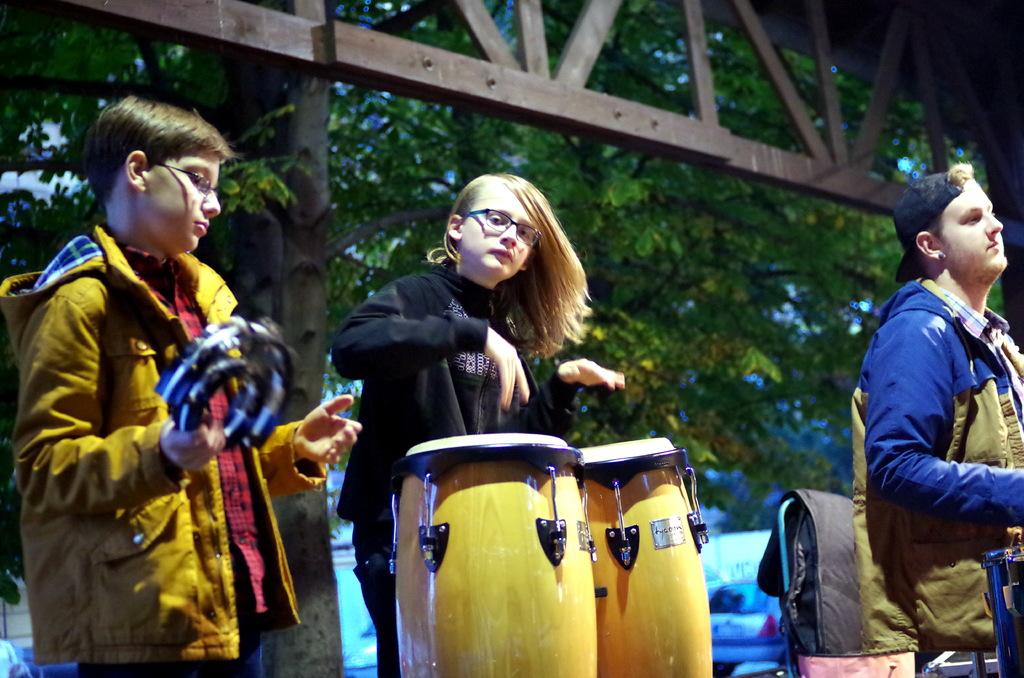How many people are present in the image? There are three people in the image. What are the people doing in the image? The people are playing musical instruments. What can be seen in the background of the image? There are trees and cars in the background of the image. What time of day is it in the image, and how many girls are present? The time of day is not mentioned in the image, and there is no indication of the number of girls present, as the image only shows three people playing musical instruments. Can you tell me which tooth is missing in the image? There are no people or teeth visible in the image; it features three people playing musical instruments. 